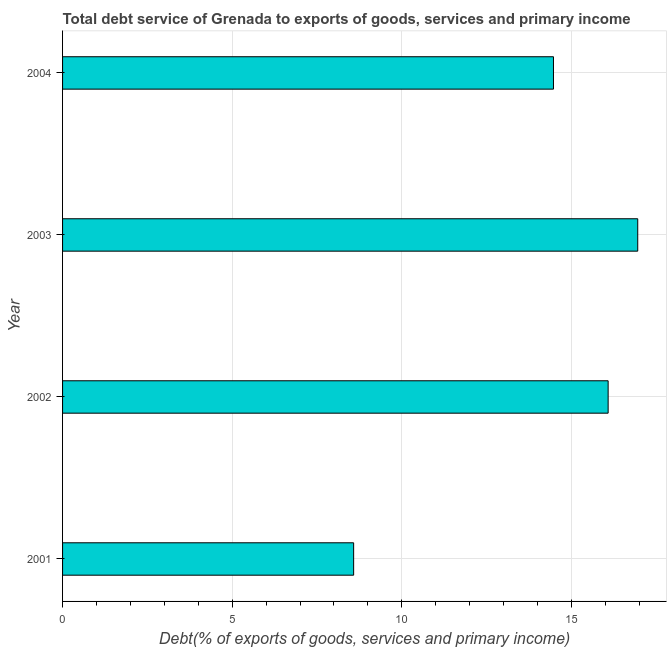Does the graph contain grids?
Your answer should be very brief. Yes. What is the title of the graph?
Keep it short and to the point. Total debt service of Grenada to exports of goods, services and primary income. What is the label or title of the X-axis?
Offer a terse response. Debt(% of exports of goods, services and primary income). What is the total debt service in 2002?
Your answer should be very brief. 16.08. Across all years, what is the maximum total debt service?
Keep it short and to the point. 16.95. Across all years, what is the minimum total debt service?
Offer a terse response. 8.58. In which year was the total debt service maximum?
Your answer should be very brief. 2003. In which year was the total debt service minimum?
Provide a short and direct response. 2001. What is the sum of the total debt service?
Your response must be concise. 56.08. What is the difference between the total debt service in 2003 and 2004?
Give a very brief answer. 2.48. What is the average total debt service per year?
Your answer should be very brief. 14.02. What is the median total debt service?
Ensure brevity in your answer.  15.27. In how many years, is the total debt service greater than 14 %?
Make the answer very short. 3. What is the ratio of the total debt service in 2001 to that in 2002?
Ensure brevity in your answer.  0.53. Is the difference between the total debt service in 2001 and 2002 greater than the difference between any two years?
Ensure brevity in your answer.  No. What is the difference between the highest and the second highest total debt service?
Your response must be concise. 0.87. What is the difference between the highest and the lowest total debt service?
Offer a terse response. 8.37. How many bars are there?
Offer a very short reply. 4. What is the Debt(% of exports of goods, services and primary income) in 2001?
Your answer should be compact. 8.58. What is the Debt(% of exports of goods, services and primary income) of 2002?
Your answer should be compact. 16.08. What is the Debt(% of exports of goods, services and primary income) in 2003?
Give a very brief answer. 16.95. What is the Debt(% of exports of goods, services and primary income) in 2004?
Your response must be concise. 14.47. What is the difference between the Debt(% of exports of goods, services and primary income) in 2001 and 2002?
Your answer should be very brief. -7.5. What is the difference between the Debt(% of exports of goods, services and primary income) in 2001 and 2003?
Make the answer very short. -8.37. What is the difference between the Debt(% of exports of goods, services and primary income) in 2001 and 2004?
Give a very brief answer. -5.89. What is the difference between the Debt(% of exports of goods, services and primary income) in 2002 and 2003?
Give a very brief answer. -0.87. What is the difference between the Debt(% of exports of goods, services and primary income) in 2002 and 2004?
Ensure brevity in your answer.  1.61. What is the difference between the Debt(% of exports of goods, services and primary income) in 2003 and 2004?
Your answer should be compact. 2.48. What is the ratio of the Debt(% of exports of goods, services and primary income) in 2001 to that in 2002?
Keep it short and to the point. 0.53. What is the ratio of the Debt(% of exports of goods, services and primary income) in 2001 to that in 2003?
Keep it short and to the point. 0.51. What is the ratio of the Debt(% of exports of goods, services and primary income) in 2001 to that in 2004?
Offer a terse response. 0.59. What is the ratio of the Debt(% of exports of goods, services and primary income) in 2002 to that in 2003?
Keep it short and to the point. 0.95. What is the ratio of the Debt(% of exports of goods, services and primary income) in 2002 to that in 2004?
Make the answer very short. 1.11. What is the ratio of the Debt(% of exports of goods, services and primary income) in 2003 to that in 2004?
Offer a very short reply. 1.17. 